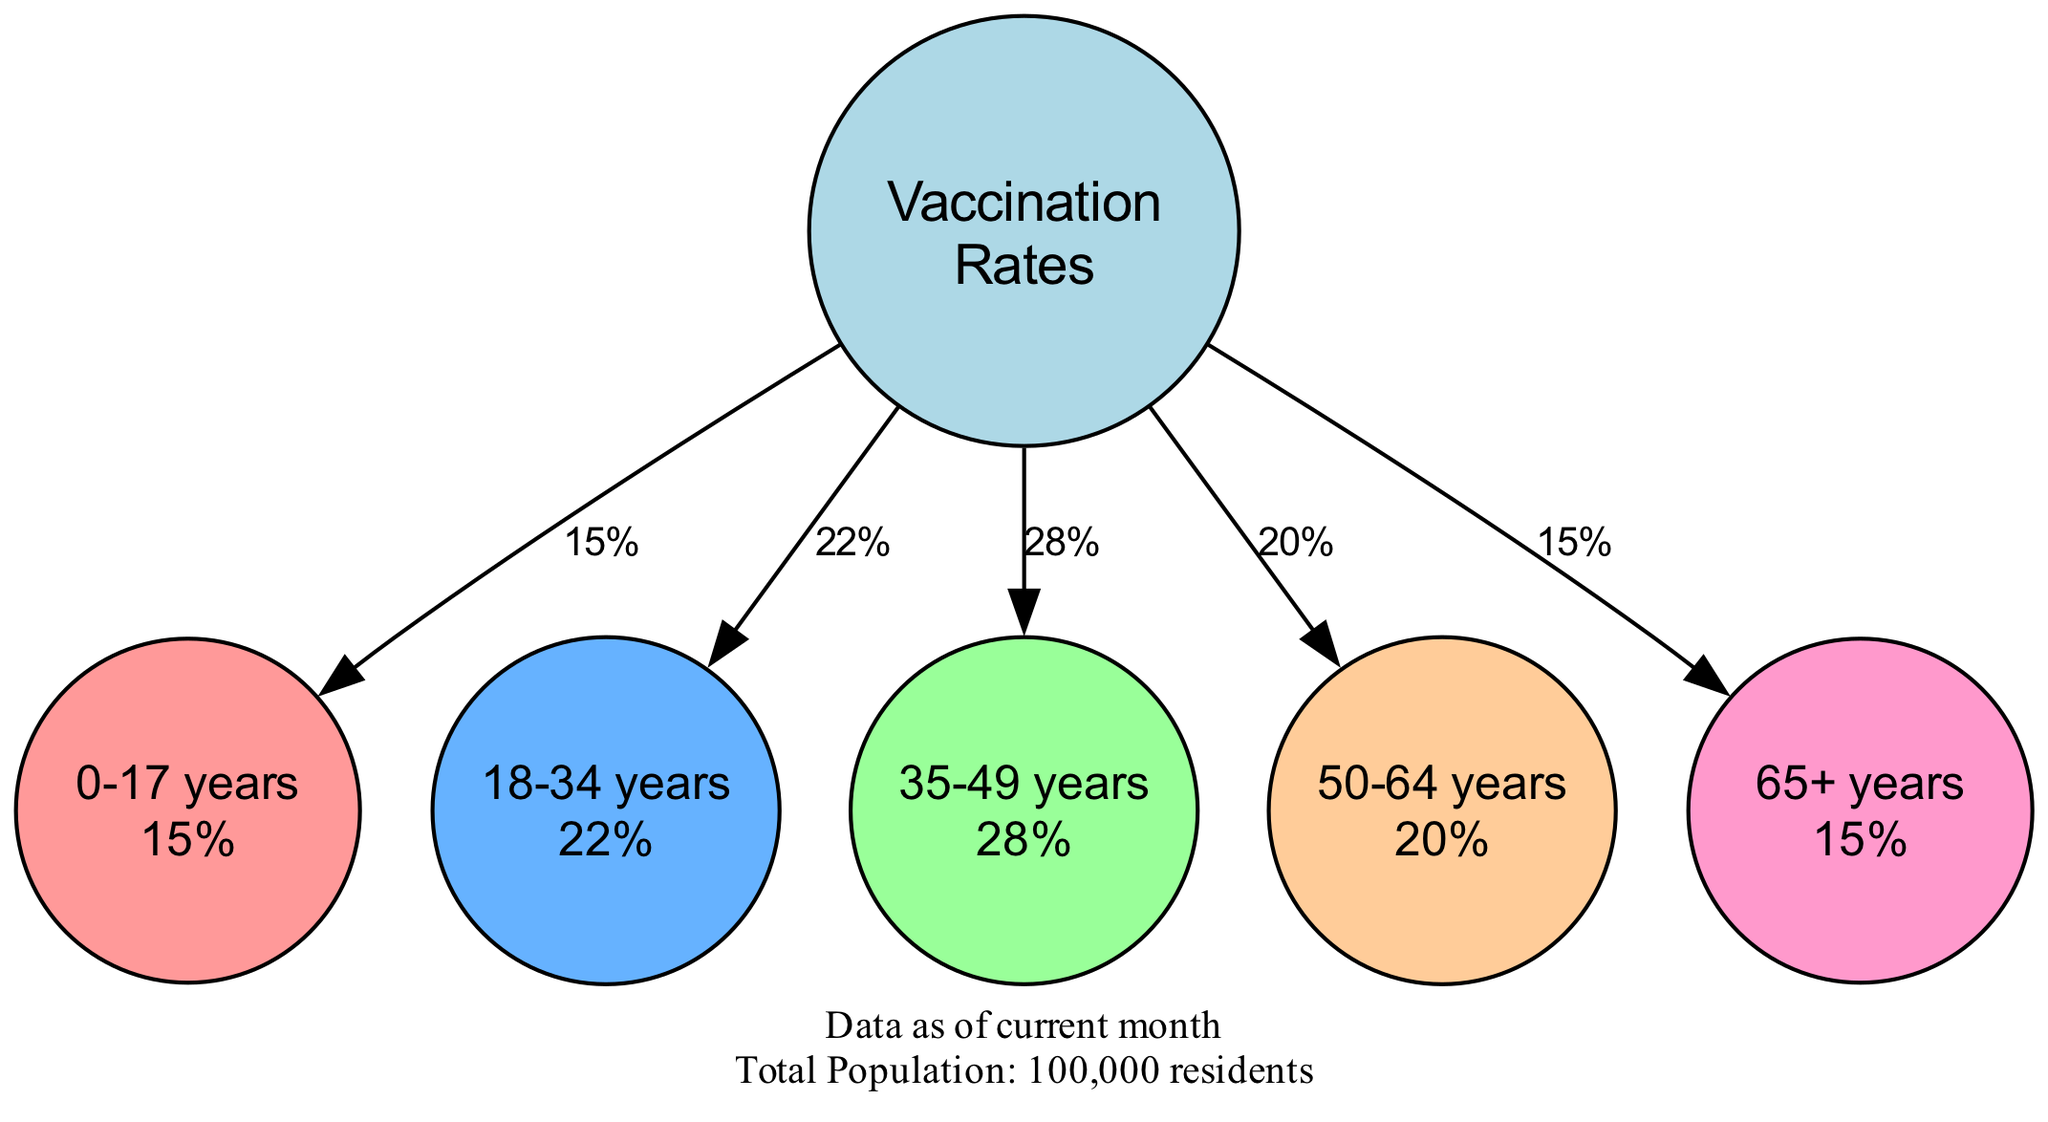What is the percentage of vaccinated individuals aged 18-34 years? According to the pie chart, the age group "18-34 years" corresponds to a slice that shows a percentage of 22%.
Answer: 22% What age group has the highest vaccination rate? The age group "35-49 years" has the largest slice in the pie chart, indicating that it has the highest vaccination rate at 28%.
Answer: 35-49 years How many total groups are represented in the pie chart? There are five distinct age groups listed in the pie chart, namely 0-17 years, 18-34 years, 35-49 years, 50-64 years, and 65+ years.
Answer: 5 What is the combined percentage of vaccinated individuals aged 0-17 years and 65+ years? The respective percentages for the age group "0-17 years" is 15%, and for "65+ years" is 15%. Thus, combining these yields 15% + 15% = 30%.
Answer: 30% What color represents the age group 50-64 years? The color for the age group "50-64 years" is represented in the pie chart as orange (hex code #FFCC99).
Answer: Orange What is the total number of residents represented in this data? The diagram indicates that the total population represented in this data is 100,000 residents.
Answer: 100,000 residents Which age group has the lowest vaccination rate? The "0-17 years" and "65+ years" age groups are both at 15%, making them the lowest vaccination rate groups displayed in the diagram.
Answer: 0-17 years and 65+ years What does the legend of the pie chart indicate? The legend states that it shows the percentage of vaccinated individuals, indicating what the percentages in the pie chart represent.
Answer: Percentage of Vaccinated Individuals What is the data source for the information in the diagram? The pie chart specifies that the data source for the vaccination rates is the "Local Health Department Records."
Answer: Local Health Department Records 